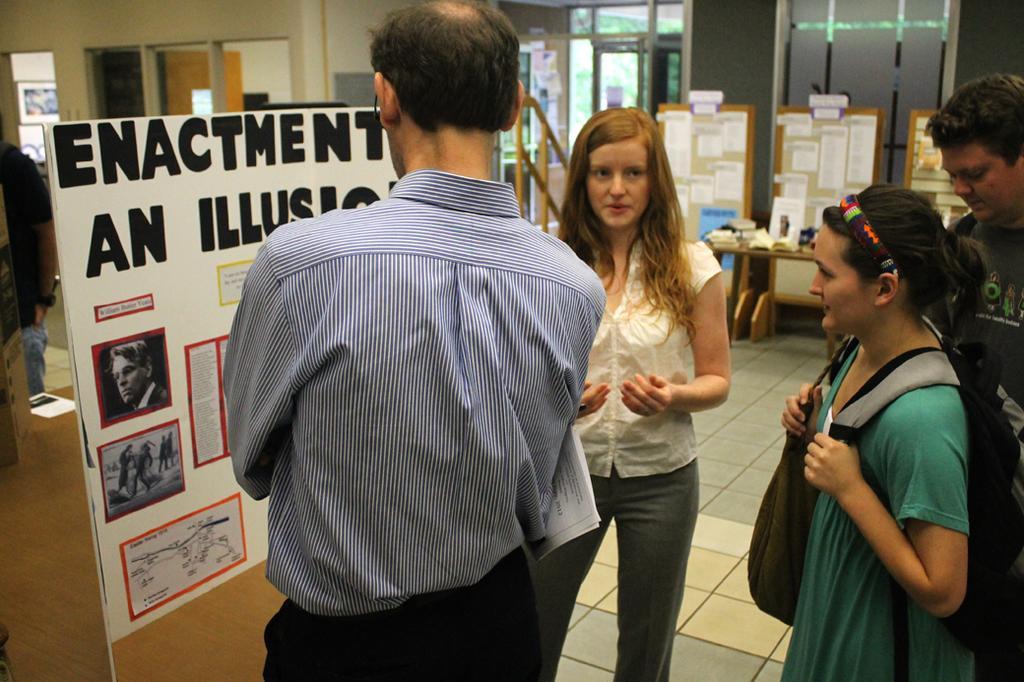Can you describe this image briefly? In this picture we can see a few people standing. We can see the text and a few things on the boards. There are some objects on the wooden tables. We can see glass objects and other objects in the background. 